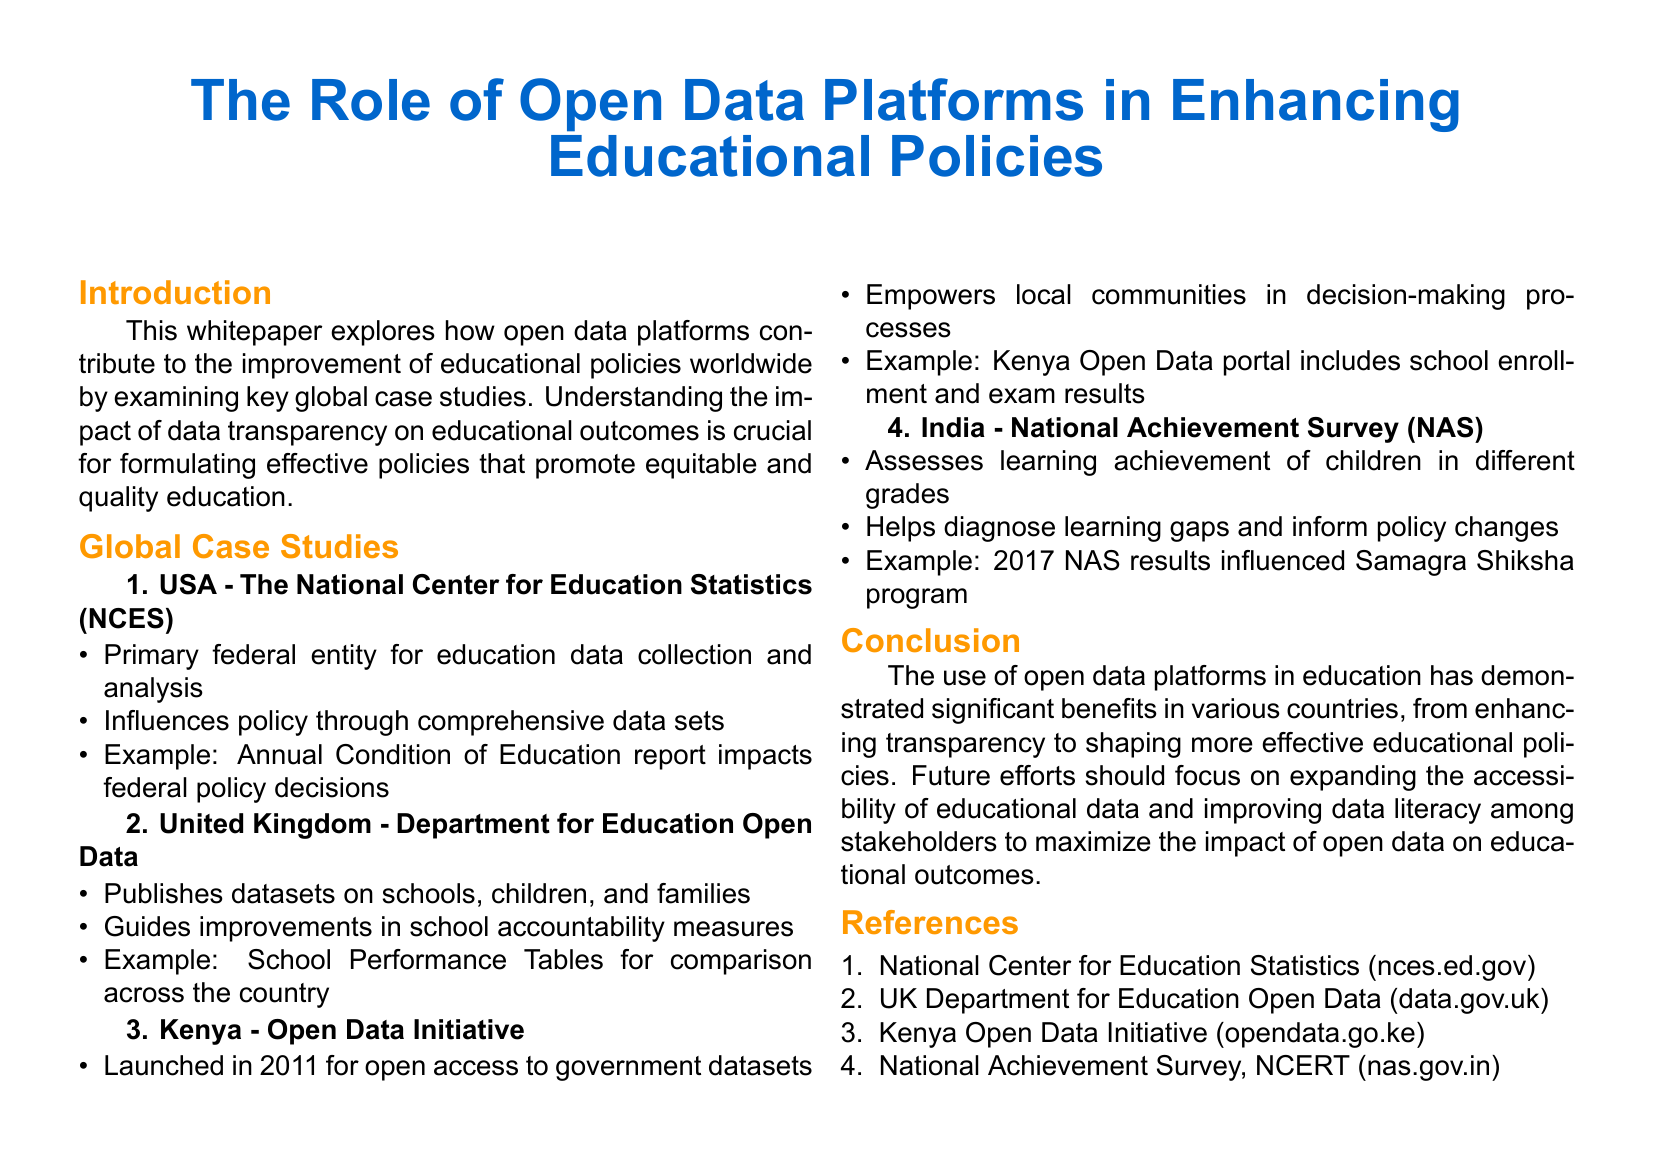what is the title of the whitepaper? The title is stated at the top of the document: "The Role of Open Data Platforms in Enhancing Educational Policies".
Answer: The Role of Open Data Platforms in Enhancing Educational Policies who is the primary federal entity for education data collection in the USA? The document explicitly states that the primary federal entity is the National Center for Education Statistics (NCES).
Answer: National Center for Education Statistics (NCES) what year was the Kenya Open Data Initiative launched? The year of launch is mentioned in the Kenya case study in the document as 2011.
Answer: 2011 which program was influenced by the 2017 National Achievement Survey results in India? The document connects the 2017 National Achievement Survey results to the Samagra Shiksha program.
Answer: Samagra Shiksha what type of data does the UK Department for Education publish? The document specifies that the Department publishes datasets on schools, children, and families.
Answer: datasets on schools, children, and families how many global case studies are presented in the whitepaper? The document lists exactly four case studies in the Global Case Studies section.
Answer: four what is a key benefit of open data platforms in education mentioned in the conclusion? The conclusion emphasizes that one of the significant benefits is enhancing transparency in educational policies.
Answer: enhancing transparency what does the Kenya Open Data portal include? The document highlights that the portal includes school enrollment and exam results.
Answer: school enrollment and exam results 